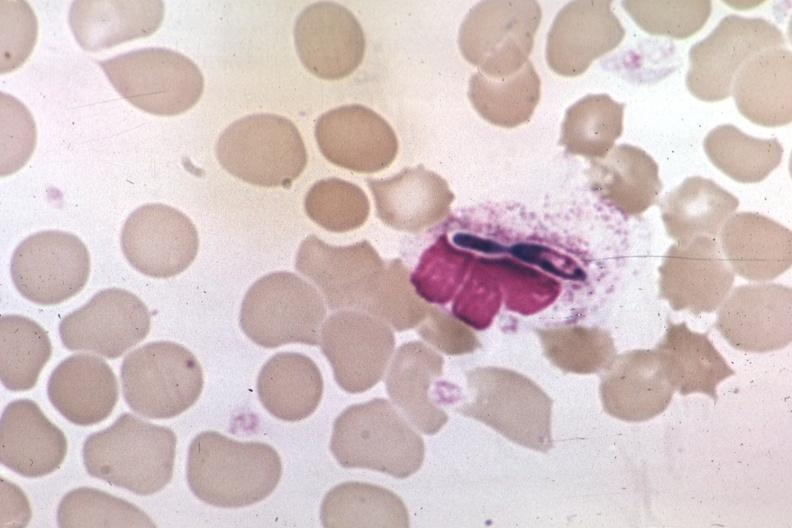what does this image show?
Answer the question using a single word or phrase. Wrights in macrophage 